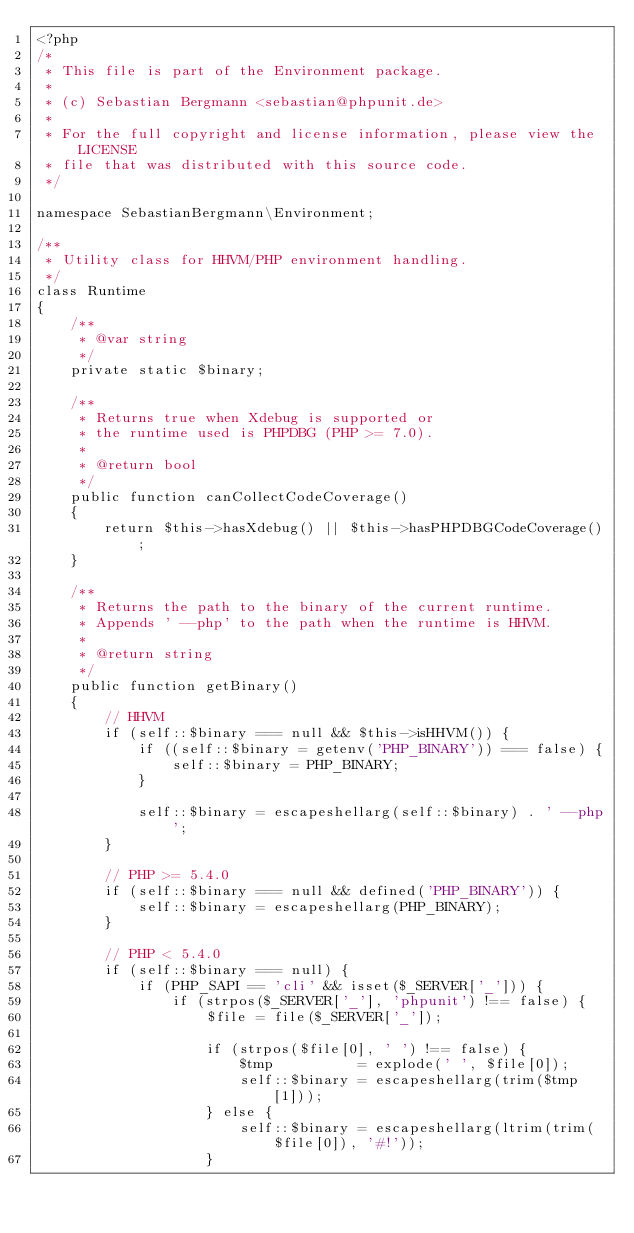Convert code to text. <code><loc_0><loc_0><loc_500><loc_500><_PHP_><?php
/*
 * This file is part of the Environment package.
 *
 * (c) Sebastian Bergmann <sebastian@phpunit.de>
 *
 * For the full copyright and license information, please view the LICENSE
 * file that was distributed with this source code.
 */

namespace SebastianBergmann\Environment;

/**
 * Utility class for HHVM/PHP environment handling.
 */
class Runtime
{
    /**
     * @var string
     */
    private static $binary;

    /**
     * Returns true when Xdebug is supported or
     * the runtime used is PHPDBG (PHP >= 7.0).
     *
     * @return bool
     */
    public function canCollectCodeCoverage()
    {
        return $this->hasXdebug() || $this->hasPHPDBGCodeCoverage();
    }

    /**
     * Returns the path to the binary of the current runtime.
     * Appends ' --php' to the path when the runtime is HHVM.
     *
     * @return string
     */
    public function getBinary()
    {
        // HHVM
        if (self::$binary === null && $this->isHHVM()) {
            if ((self::$binary = getenv('PHP_BINARY')) === false) {
                self::$binary = PHP_BINARY;
            }

            self::$binary = escapeshellarg(self::$binary) . ' --php';
        }

        // PHP >= 5.4.0
        if (self::$binary === null && defined('PHP_BINARY')) {
            self::$binary = escapeshellarg(PHP_BINARY);
        }

        // PHP < 5.4.0
        if (self::$binary === null) {
            if (PHP_SAPI == 'cli' && isset($_SERVER['_'])) {
                if (strpos($_SERVER['_'], 'phpunit') !== false) {
                    $file = file($_SERVER['_']);

                    if (strpos($file[0], ' ') !== false) {
                        $tmp          = explode(' ', $file[0]);
                        self::$binary = escapeshellarg(trim($tmp[1]));
                    } else {
                        self::$binary = escapeshellarg(ltrim(trim($file[0]), '#!'));
                    }</code> 